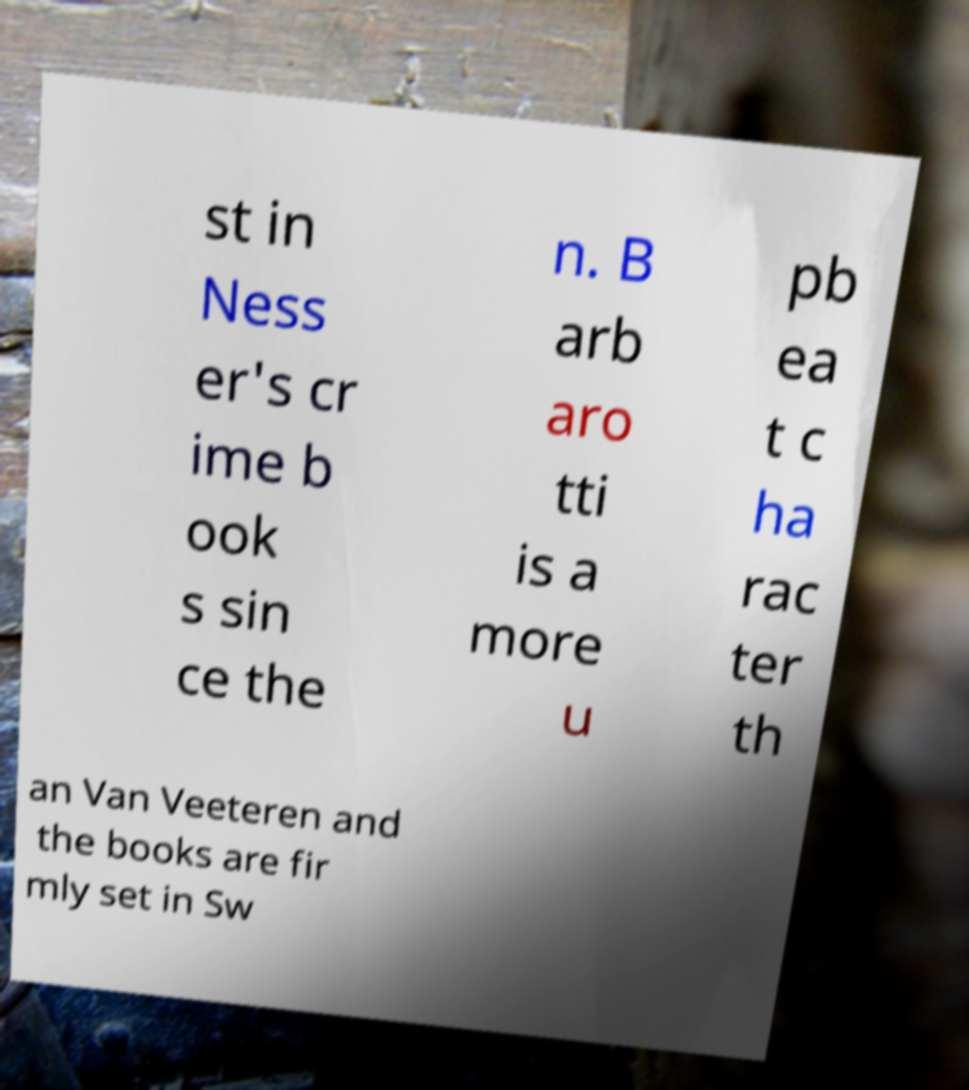For documentation purposes, I need the text within this image transcribed. Could you provide that? st in Ness er's cr ime b ook s sin ce the n. B arb aro tti is a more u pb ea t c ha rac ter th an Van Veeteren and the books are fir mly set in Sw 